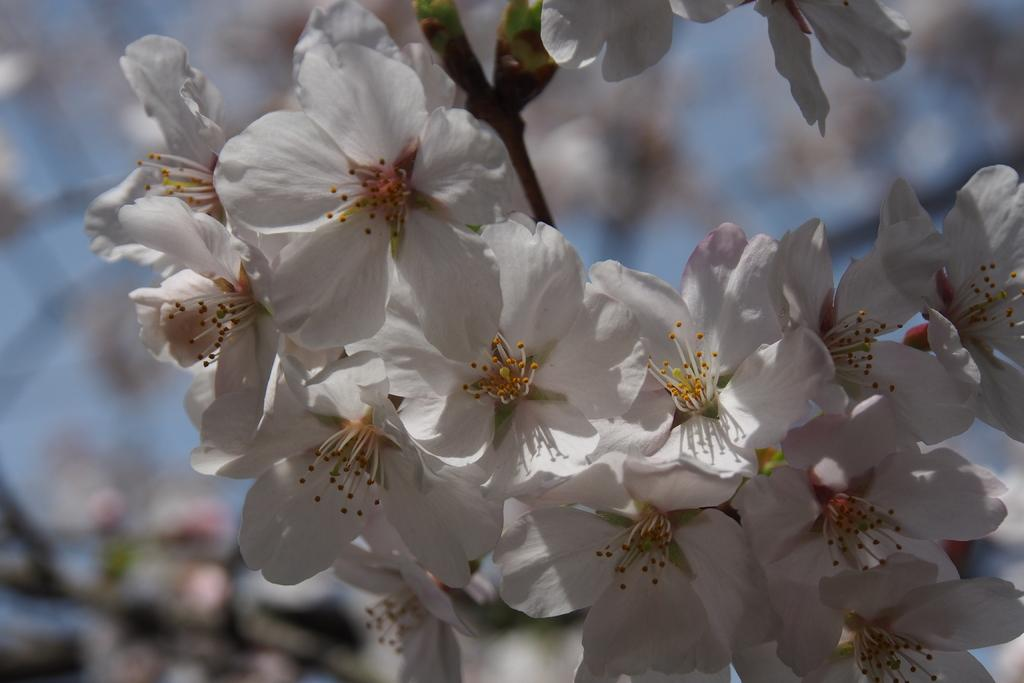What type of flowers are in the image? There are white cherry blossoms in the image. Can you describe the background of the image? The background of the image is blurred. What type of cracker is visible in the image? There is no cracker present in the image. 